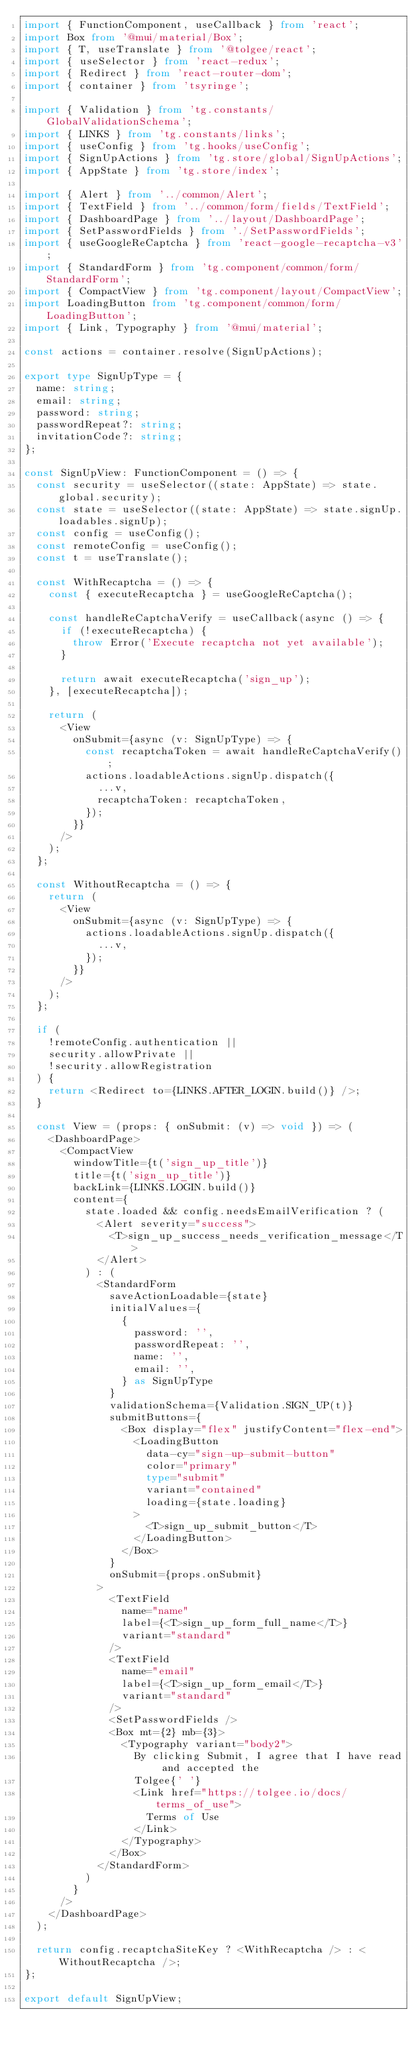Convert code to text. <code><loc_0><loc_0><loc_500><loc_500><_TypeScript_>import { FunctionComponent, useCallback } from 'react';
import Box from '@mui/material/Box';
import { T, useTranslate } from '@tolgee/react';
import { useSelector } from 'react-redux';
import { Redirect } from 'react-router-dom';
import { container } from 'tsyringe';

import { Validation } from 'tg.constants/GlobalValidationSchema';
import { LINKS } from 'tg.constants/links';
import { useConfig } from 'tg.hooks/useConfig';
import { SignUpActions } from 'tg.store/global/SignUpActions';
import { AppState } from 'tg.store/index';

import { Alert } from '../common/Alert';
import { TextField } from '../common/form/fields/TextField';
import { DashboardPage } from '../layout/DashboardPage';
import { SetPasswordFields } from './SetPasswordFields';
import { useGoogleReCaptcha } from 'react-google-recaptcha-v3';
import { StandardForm } from 'tg.component/common/form/StandardForm';
import { CompactView } from 'tg.component/layout/CompactView';
import LoadingButton from 'tg.component/common/form/LoadingButton';
import { Link, Typography } from '@mui/material';

const actions = container.resolve(SignUpActions);

export type SignUpType = {
  name: string;
  email: string;
  password: string;
  passwordRepeat?: string;
  invitationCode?: string;
};

const SignUpView: FunctionComponent = () => {
  const security = useSelector((state: AppState) => state.global.security);
  const state = useSelector((state: AppState) => state.signUp.loadables.signUp);
  const config = useConfig();
  const remoteConfig = useConfig();
  const t = useTranslate();

  const WithRecaptcha = () => {
    const { executeRecaptcha } = useGoogleReCaptcha();

    const handleReCaptchaVerify = useCallback(async () => {
      if (!executeRecaptcha) {
        throw Error('Execute recaptcha not yet available');
      }

      return await executeRecaptcha('sign_up');
    }, [executeRecaptcha]);

    return (
      <View
        onSubmit={async (v: SignUpType) => {
          const recaptchaToken = await handleReCaptchaVerify();
          actions.loadableActions.signUp.dispatch({
            ...v,
            recaptchaToken: recaptchaToken,
          });
        }}
      />
    );
  };

  const WithoutRecaptcha = () => {
    return (
      <View
        onSubmit={async (v: SignUpType) => {
          actions.loadableActions.signUp.dispatch({
            ...v,
          });
        }}
      />
    );
  };

  if (
    !remoteConfig.authentication ||
    security.allowPrivate ||
    !security.allowRegistration
  ) {
    return <Redirect to={LINKS.AFTER_LOGIN.build()} />;
  }

  const View = (props: { onSubmit: (v) => void }) => (
    <DashboardPage>
      <CompactView
        windowTitle={t('sign_up_title')}
        title={t('sign_up_title')}
        backLink={LINKS.LOGIN.build()}
        content={
          state.loaded && config.needsEmailVerification ? (
            <Alert severity="success">
              <T>sign_up_success_needs_verification_message</T>
            </Alert>
          ) : (
            <StandardForm
              saveActionLoadable={state}
              initialValues={
                {
                  password: '',
                  passwordRepeat: '',
                  name: '',
                  email: '',
                } as SignUpType
              }
              validationSchema={Validation.SIGN_UP(t)}
              submitButtons={
                <Box display="flex" justifyContent="flex-end">
                  <LoadingButton
                    data-cy="sign-up-submit-button"
                    color="primary"
                    type="submit"
                    variant="contained"
                    loading={state.loading}
                  >
                    <T>sign_up_submit_button</T>
                  </LoadingButton>
                </Box>
              }
              onSubmit={props.onSubmit}
            >
              <TextField
                name="name"
                label={<T>sign_up_form_full_name</T>}
                variant="standard"
              />
              <TextField
                name="email"
                label={<T>sign_up_form_email</T>}
                variant="standard"
              />
              <SetPasswordFields />
              <Box mt={2} mb={3}>
                <Typography variant="body2">
                  By clicking Submit, I agree that I have read and accepted the
                  Tolgee{' '}
                  <Link href="https://tolgee.io/docs/terms_of_use">
                    Terms of Use
                  </Link>
                </Typography>
              </Box>
            </StandardForm>
          )
        }
      />
    </DashboardPage>
  );

  return config.recaptchaSiteKey ? <WithRecaptcha /> : <WithoutRecaptcha />;
};

export default SignUpView;
</code> 